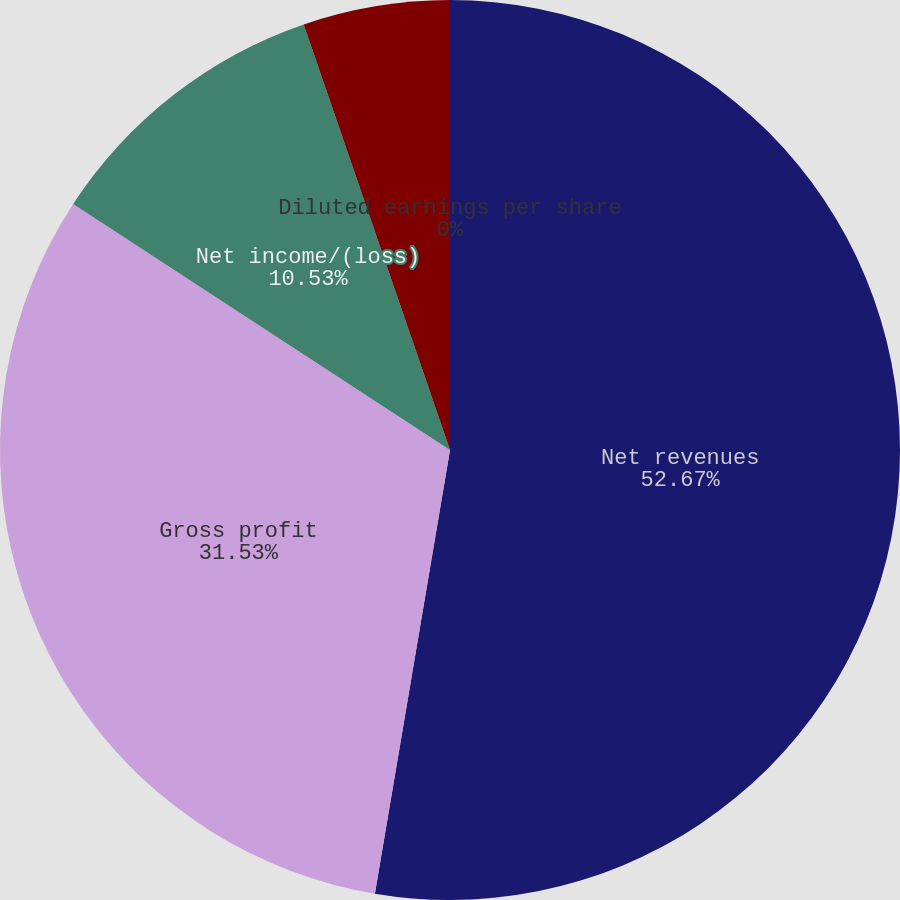<chart> <loc_0><loc_0><loc_500><loc_500><pie_chart><fcel>Net revenues<fcel>Gross profit<fcel>Net income/(loss)<fcel>Basic earnings per share<fcel>Diluted earnings per share<nl><fcel>52.67%<fcel>31.53%<fcel>10.53%<fcel>5.27%<fcel>0.0%<nl></chart> 